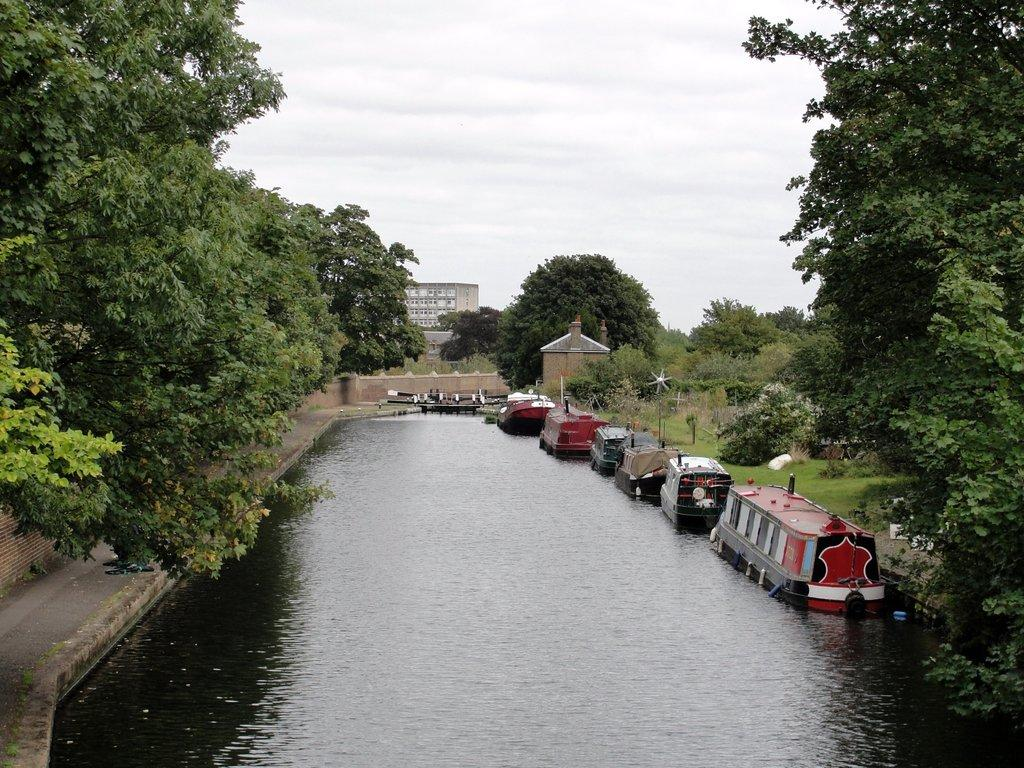What is the primary element visible in the image? There is water in the image. What types of vehicles can be seen in the image? There are boats in the image. What type of vegetation is present in the image? There are trees in the image. What type of structure is visible in the image? There is a house in the image. What type of man-made structures are present in the image? There are buildings in the image. What type of illumination is visible in the image? There are lights in the image. What type of ground surface is present in the image? There is grass in the image. What part of the natural environment is visible in the image? The sky is visible in the image. What type of atmospheric conditions can be observed in the image? There are clouds in the image. What type of metal is being driven through the water in the image? There is no metal being driven through the water in the image; it features boats on the water. What type of liquid is being poured from the sky in the image? There is no liquid being poured from the sky in the image; it features clouds in the sky. 